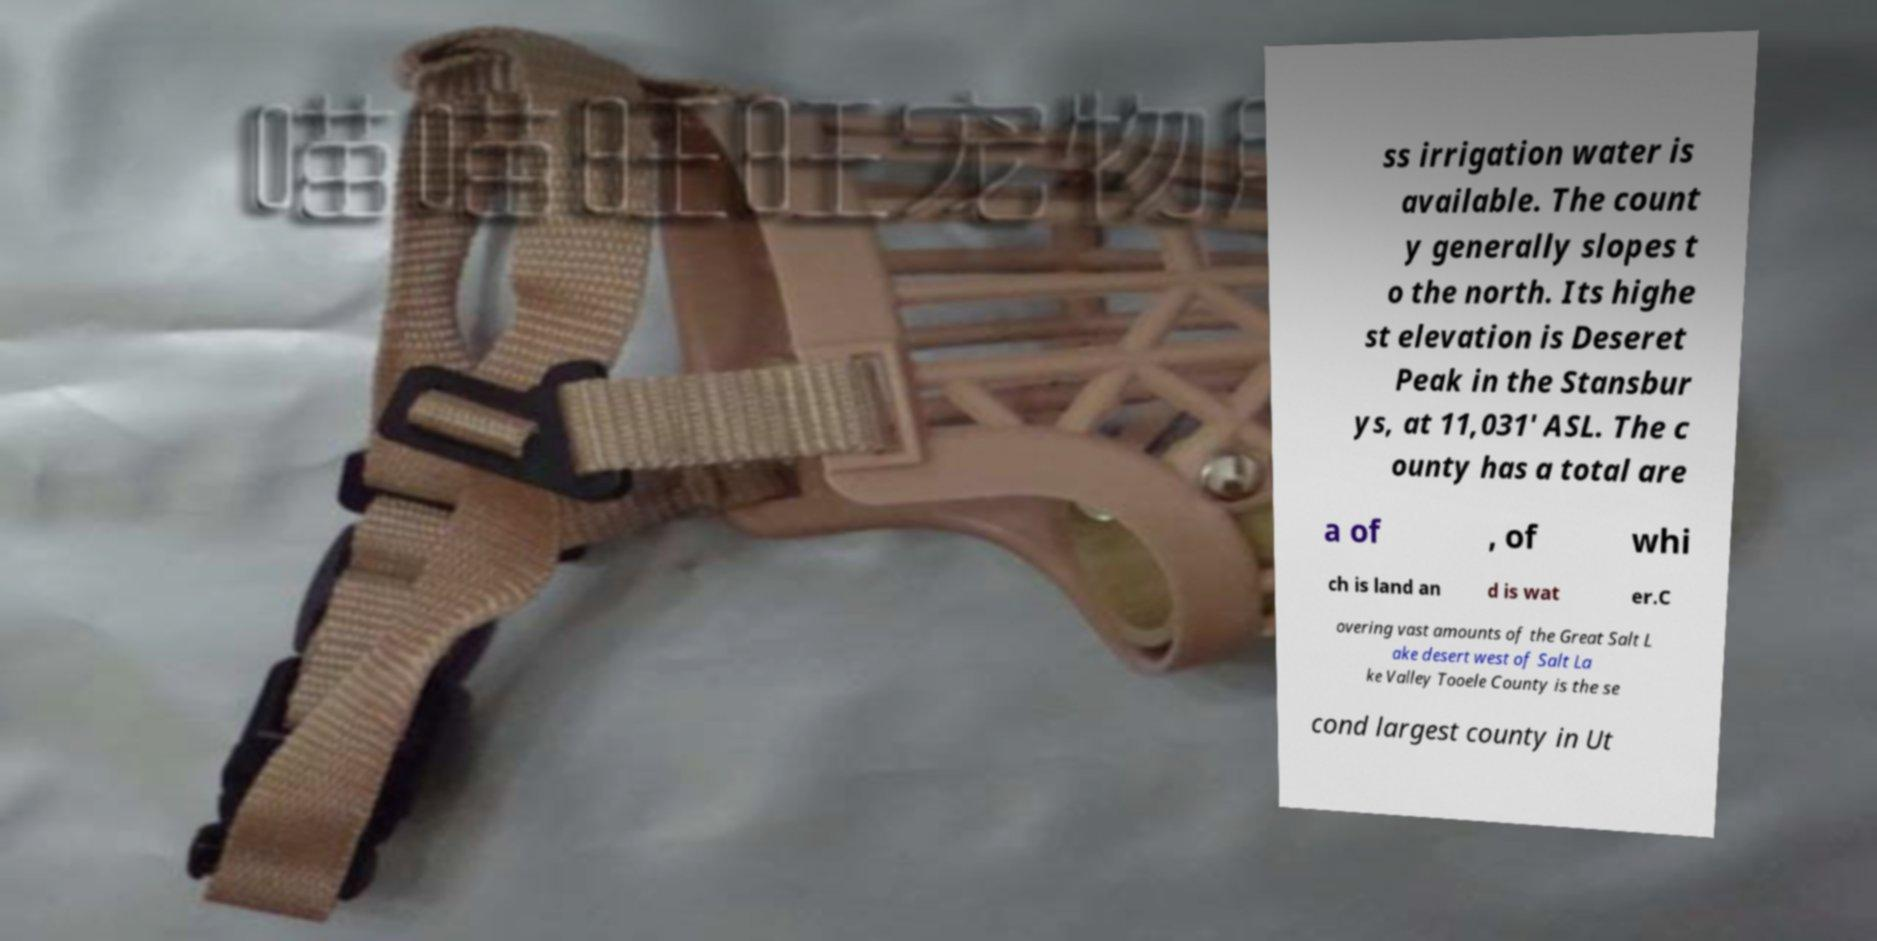Could you extract and type out the text from this image? ss irrigation water is available. The count y generally slopes t o the north. Its highe st elevation is Deseret Peak in the Stansbur ys, at 11,031' ASL. The c ounty has a total are a of , of whi ch is land an d is wat er.C overing vast amounts of the Great Salt L ake desert west of Salt La ke Valley Tooele County is the se cond largest county in Ut 